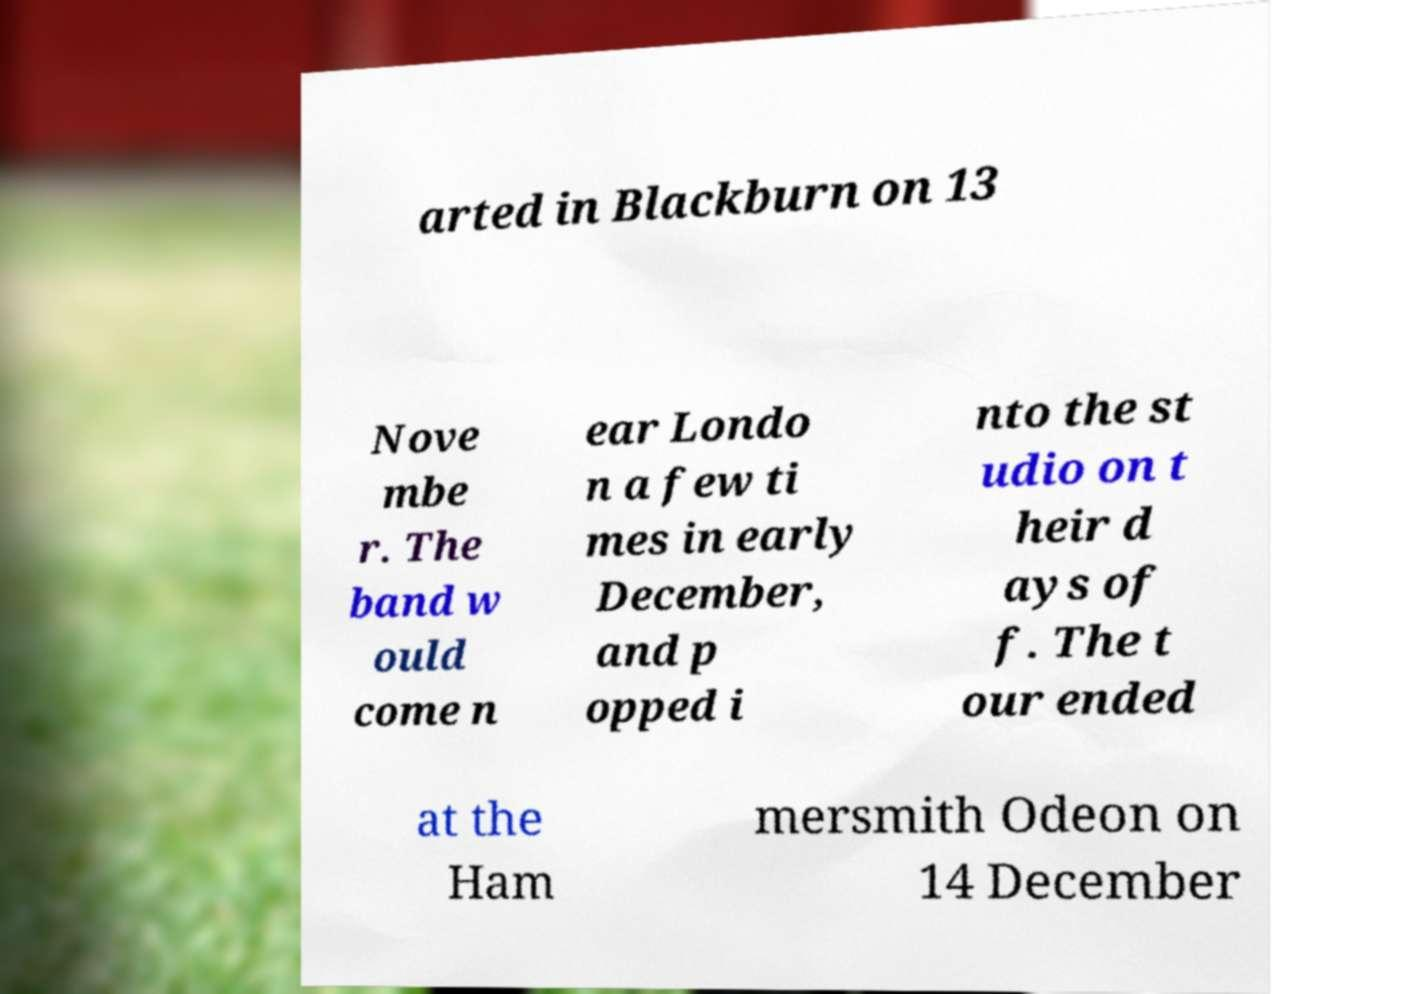I need the written content from this picture converted into text. Can you do that? arted in Blackburn on 13 Nove mbe r. The band w ould come n ear Londo n a few ti mes in early December, and p opped i nto the st udio on t heir d ays of f. The t our ended at the Ham mersmith Odeon on 14 December 